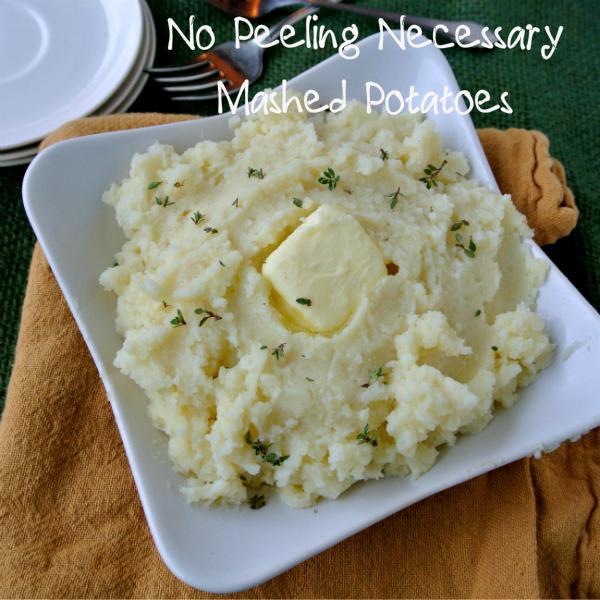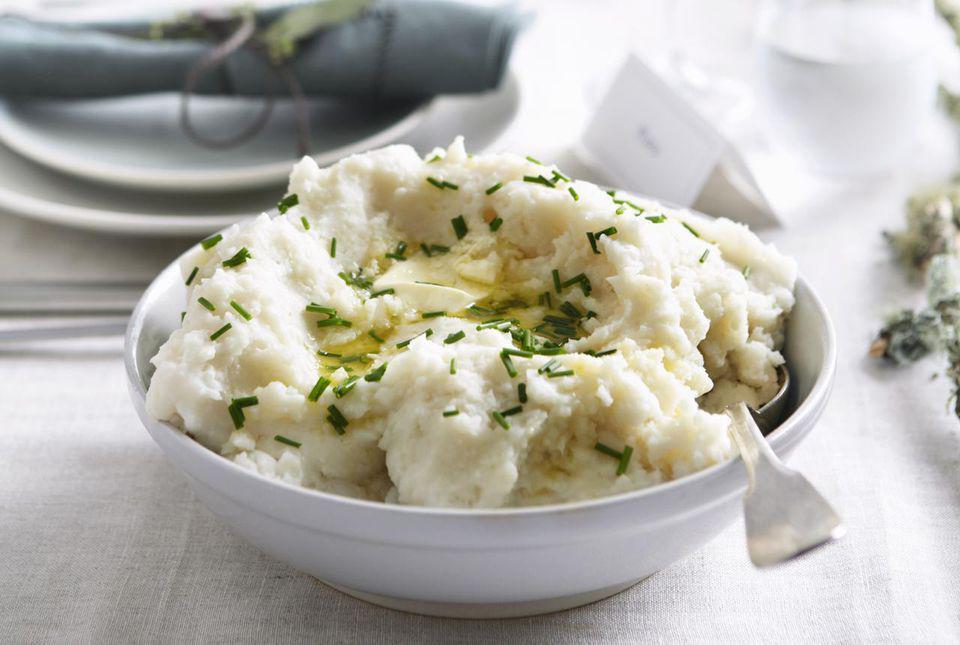The first image is the image on the left, the second image is the image on the right. Examine the images to the left and right. Is the description "Mashed potatoes are in a squared white dish in one image." accurate? Answer yes or no. Yes. The first image is the image on the left, the second image is the image on the right. Analyze the images presented: Is the assertion "The potatoes in the image on the left are served in a square shaped bowl." valid? Answer yes or no. Yes. 